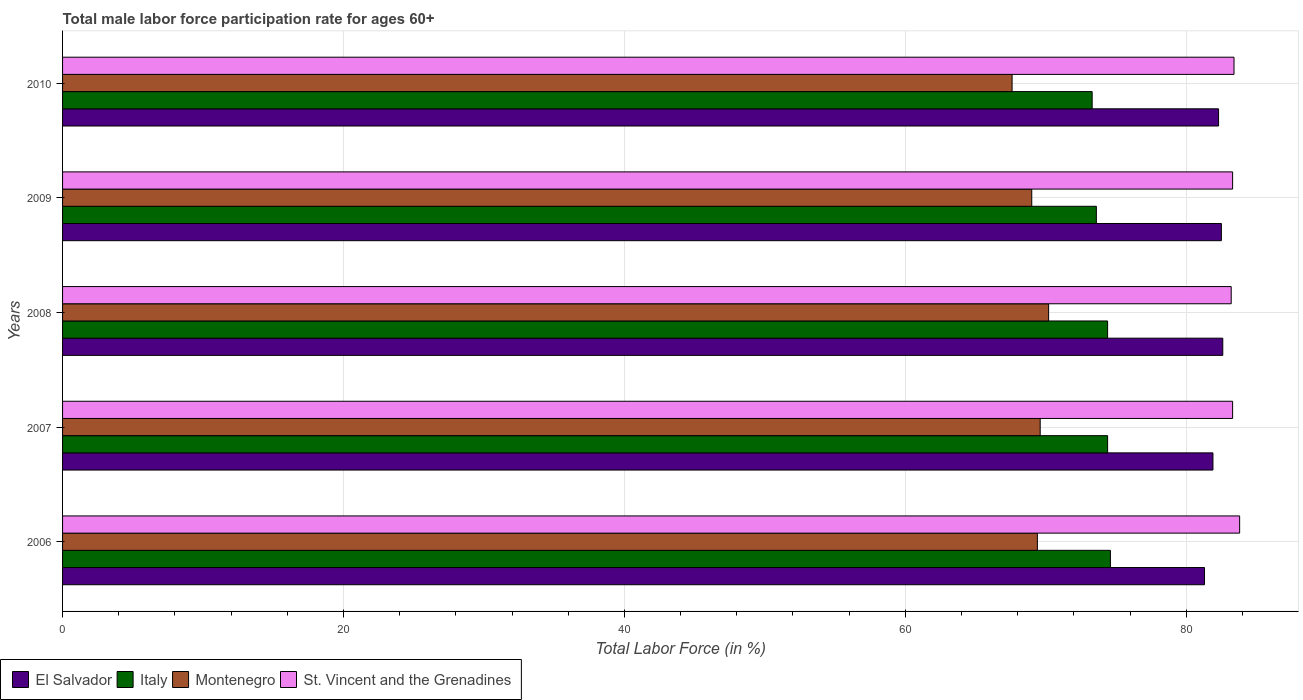How many groups of bars are there?
Keep it short and to the point. 5. Are the number of bars per tick equal to the number of legend labels?
Ensure brevity in your answer.  Yes. How many bars are there on the 3rd tick from the top?
Give a very brief answer. 4. How many bars are there on the 5th tick from the bottom?
Your answer should be very brief. 4. What is the male labor force participation rate in El Salvador in 2009?
Offer a terse response. 82.5. Across all years, what is the maximum male labor force participation rate in Montenegro?
Offer a terse response. 70.2. Across all years, what is the minimum male labor force participation rate in St. Vincent and the Grenadines?
Your answer should be compact. 83.2. In which year was the male labor force participation rate in El Salvador maximum?
Make the answer very short. 2008. What is the total male labor force participation rate in Montenegro in the graph?
Ensure brevity in your answer.  345.8. What is the difference between the male labor force participation rate in Montenegro in 2007 and that in 2009?
Keep it short and to the point. 0.6. What is the difference between the male labor force participation rate in Montenegro in 2006 and the male labor force participation rate in St. Vincent and the Grenadines in 2009?
Make the answer very short. -13.9. What is the average male labor force participation rate in Italy per year?
Your response must be concise. 74.06. In the year 2010, what is the difference between the male labor force participation rate in Italy and male labor force participation rate in St. Vincent and the Grenadines?
Ensure brevity in your answer.  -10.1. In how many years, is the male labor force participation rate in Montenegro greater than 68 %?
Your response must be concise. 4. What is the ratio of the male labor force participation rate in St. Vincent and the Grenadines in 2007 to that in 2010?
Your answer should be very brief. 1. Is the male labor force participation rate in Italy in 2008 less than that in 2010?
Provide a succinct answer. No. Is the difference between the male labor force participation rate in Italy in 2006 and 2008 greater than the difference between the male labor force participation rate in St. Vincent and the Grenadines in 2006 and 2008?
Offer a very short reply. No. What is the difference between the highest and the second highest male labor force participation rate in St. Vincent and the Grenadines?
Provide a short and direct response. 0.4. What is the difference between the highest and the lowest male labor force participation rate in El Salvador?
Your response must be concise. 1.3. In how many years, is the male labor force participation rate in Montenegro greater than the average male labor force participation rate in Montenegro taken over all years?
Keep it short and to the point. 3. Is the sum of the male labor force participation rate in Italy in 2008 and 2010 greater than the maximum male labor force participation rate in Montenegro across all years?
Ensure brevity in your answer.  Yes. Is it the case that in every year, the sum of the male labor force participation rate in St. Vincent and the Grenadines and male labor force participation rate in Italy is greater than the sum of male labor force participation rate in El Salvador and male labor force participation rate in Montenegro?
Provide a succinct answer. No. What does the 2nd bar from the top in 2007 represents?
Ensure brevity in your answer.  Montenegro. Is it the case that in every year, the sum of the male labor force participation rate in St. Vincent and the Grenadines and male labor force participation rate in Montenegro is greater than the male labor force participation rate in El Salvador?
Your response must be concise. Yes. Are all the bars in the graph horizontal?
Keep it short and to the point. Yes. How many years are there in the graph?
Your answer should be compact. 5. How are the legend labels stacked?
Your response must be concise. Horizontal. What is the title of the graph?
Your answer should be very brief. Total male labor force participation rate for ages 60+. What is the label or title of the X-axis?
Your response must be concise. Total Labor Force (in %). What is the label or title of the Y-axis?
Provide a short and direct response. Years. What is the Total Labor Force (in %) of El Salvador in 2006?
Give a very brief answer. 81.3. What is the Total Labor Force (in %) of Italy in 2006?
Provide a short and direct response. 74.6. What is the Total Labor Force (in %) in Montenegro in 2006?
Your answer should be compact. 69.4. What is the Total Labor Force (in %) in St. Vincent and the Grenadines in 2006?
Provide a short and direct response. 83.8. What is the Total Labor Force (in %) in El Salvador in 2007?
Offer a very short reply. 81.9. What is the Total Labor Force (in %) in Italy in 2007?
Your answer should be compact. 74.4. What is the Total Labor Force (in %) in Montenegro in 2007?
Your answer should be compact. 69.6. What is the Total Labor Force (in %) of St. Vincent and the Grenadines in 2007?
Your response must be concise. 83.3. What is the Total Labor Force (in %) of El Salvador in 2008?
Provide a short and direct response. 82.6. What is the Total Labor Force (in %) of Italy in 2008?
Provide a short and direct response. 74.4. What is the Total Labor Force (in %) in Montenegro in 2008?
Keep it short and to the point. 70.2. What is the Total Labor Force (in %) of St. Vincent and the Grenadines in 2008?
Provide a succinct answer. 83.2. What is the Total Labor Force (in %) in El Salvador in 2009?
Offer a very short reply. 82.5. What is the Total Labor Force (in %) of Italy in 2009?
Keep it short and to the point. 73.6. What is the Total Labor Force (in %) of St. Vincent and the Grenadines in 2009?
Offer a terse response. 83.3. What is the Total Labor Force (in %) in El Salvador in 2010?
Ensure brevity in your answer.  82.3. What is the Total Labor Force (in %) in Italy in 2010?
Offer a terse response. 73.3. What is the Total Labor Force (in %) in Montenegro in 2010?
Give a very brief answer. 67.6. What is the Total Labor Force (in %) of St. Vincent and the Grenadines in 2010?
Keep it short and to the point. 83.4. Across all years, what is the maximum Total Labor Force (in %) of El Salvador?
Give a very brief answer. 82.6. Across all years, what is the maximum Total Labor Force (in %) of Italy?
Offer a very short reply. 74.6. Across all years, what is the maximum Total Labor Force (in %) in Montenegro?
Your answer should be compact. 70.2. Across all years, what is the maximum Total Labor Force (in %) of St. Vincent and the Grenadines?
Provide a short and direct response. 83.8. Across all years, what is the minimum Total Labor Force (in %) in El Salvador?
Your answer should be compact. 81.3. Across all years, what is the minimum Total Labor Force (in %) of Italy?
Offer a terse response. 73.3. Across all years, what is the minimum Total Labor Force (in %) in Montenegro?
Offer a very short reply. 67.6. Across all years, what is the minimum Total Labor Force (in %) of St. Vincent and the Grenadines?
Offer a very short reply. 83.2. What is the total Total Labor Force (in %) of El Salvador in the graph?
Offer a terse response. 410.6. What is the total Total Labor Force (in %) in Italy in the graph?
Your answer should be very brief. 370.3. What is the total Total Labor Force (in %) in Montenegro in the graph?
Provide a short and direct response. 345.8. What is the total Total Labor Force (in %) of St. Vincent and the Grenadines in the graph?
Offer a very short reply. 417. What is the difference between the Total Labor Force (in %) of Italy in 2006 and that in 2007?
Offer a very short reply. 0.2. What is the difference between the Total Labor Force (in %) in El Salvador in 2006 and that in 2008?
Offer a terse response. -1.3. What is the difference between the Total Labor Force (in %) in Italy in 2006 and that in 2008?
Make the answer very short. 0.2. What is the difference between the Total Labor Force (in %) of El Salvador in 2006 and that in 2009?
Offer a terse response. -1.2. What is the difference between the Total Labor Force (in %) of Italy in 2006 and that in 2009?
Your answer should be compact. 1. What is the difference between the Total Labor Force (in %) of St. Vincent and the Grenadines in 2006 and that in 2009?
Provide a succinct answer. 0.5. What is the difference between the Total Labor Force (in %) of Montenegro in 2006 and that in 2010?
Keep it short and to the point. 1.8. What is the difference between the Total Labor Force (in %) in St. Vincent and the Grenadines in 2006 and that in 2010?
Offer a terse response. 0.4. What is the difference between the Total Labor Force (in %) in El Salvador in 2007 and that in 2008?
Your answer should be very brief. -0.7. What is the difference between the Total Labor Force (in %) in Italy in 2007 and that in 2008?
Offer a terse response. 0. What is the difference between the Total Labor Force (in %) of Montenegro in 2007 and that in 2008?
Ensure brevity in your answer.  -0.6. What is the difference between the Total Labor Force (in %) of St. Vincent and the Grenadines in 2007 and that in 2008?
Provide a short and direct response. 0.1. What is the difference between the Total Labor Force (in %) in El Salvador in 2007 and that in 2009?
Offer a terse response. -0.6. What is the difference between the Total Labor Force (in %) in Italy in 2007 and that in 2009?
Your answer should be compact. 0.8. What is the difference between the Total Labor Force (in %) of St. Vincent and the Grenadines in 2007 and that in 2009?
Make the answer very short. 0. What is the difference between the Total Labor Force (in %) of Italy in 2007 and that in 2010?
Provide a succinct answer. 1.1. What is the difference between the Total Labor Force (in %) of St. Vincent and the Grenadines in 2007 and that in 2010?
Offer a very short reply. -0.1. What is the difference between the Total Labor Force (in %) in Montenegro in 2008 and that in 2009?
Give a very brief answer. 1.2. What is the difference between the Total Labor Force (in %) of St. Vincent and the Grenadines in 2008 and that in 2009?
Your response must be concise. -0.1. What is the difference between the Total Labor Force (in %) in Montenegro in 2008 and that in 2010?
Offer a very short reply. 2.6. What is the difference between the Total Labor Force (in %) of St. Vincent and the Grenadines in 2008 and that in 2010?
Make the answer very short. -0.2. What is the difference between the Total Labor Force (in %) in El Salvador in 2009 and that in 2010?
Your answer should be very brief. 0.2. What is the difference between the Total Labor Force (in %) in Italy in 2009 and that in 2010?
Your response must be concise. 0.3. What is the difference between the Total Labor Force (in %) of El Salvador in 2006 and the Total Labor Force (in %) of Italy in 2007?
Give a very brief answer. 6.9. What is the difference between the Total Labor Force (in %) of El Salvador in 2006 and the Total Labor Force (in %) of Montenegro in 2007?
Give a very brief answer. 11.7. What is the difference between the Total Labor Force (in %) in El Salvador in 2006 and the Total Labor Force (in %) in St. Vincent and the Grenadines in 2007?
Offer a very short reply. -2. What is the difference between the Total Labor Force (in %) of Italy in 2006 and the Total Labor Force (in %) of St. Vincent and the Grenadines in 2007?
Your answer should be very brief. -8.7. What is the difference between the Total Labor Force (in %) in Montenegro in 2006 and the Total Labor Force (in %) in St. Vincent and the Grenadines in 2007?
Offer a terse response. -13.9. What is the difference between the Total Labor Force (in %) in El Salvador in 2006 and the Total Labor Force (in %) in Italy in 2008?
Ensure brevity in your answer.  6.9. What is the difference between the Total Labor Force (in %) in El Salvador in 2006 and the Total Labor Force (in %) in St. Vincent and the Grenadines in 2008?
Provide a short and direct response. -1.9. What is the difference between the Total Labor Force (in %) of El Salvador in 2006 and the Total Labor Force (in %) of Italy in 2009?
Your response must be concise. 7.7. What is the difference between the Total Labor Force (in %) in El Salvador in 2006 and the Total Labor Force (in %) in Italy in 2010?
Keep it short and to the point. 8. What is the difference between the Total Labor Force (in %) in El Salvador in 2006 and the Total Labor Force (in %) in St. Vincent and the Grenadines in 2010?
Your response must be concise. -2.1. What is the difference between the Total Labor Force (in %) of Italy in 2006 and the Total Labor Force (in %) of Montenegro in 2010?
Ensure brevity in your answer.  7. What is the difference between the Total Labor Force (in %) of Italy in 2006 and the Total Labor Force (in %) of St. Vincent and the Grenadines in 2010?
Provide a short and direct response. -8.8. What is the difference between the Total Labor Force (in %) in Montenegro in 2006 and the Total Labor Force (in %) in St. Vincent and the Grenadines in 2010?
Offer a terse response. -14. What is the difference between the Total Labor Force (in %) in El Salvador in 2007 and the Total Labor Force (in %) in Italy in 2008?
Provide a short and direct response. 7.5. What is the difference between the Total Labor Force (in %) of El Salvador in 2007 and the Total Labor Force (in %) of Montenegro in 2008?
Your answer should be compact. 11.7. What is the difference between the Total Labor Force (in %) of Italy in 2007 and the Total Labor Force (in %) of Montenegro in 2008?
Your answer should be very brief. 4.2. What is the difference between the Total Labor Force (in %) in Italy in 2007 and the Total Labor Force (in %) in St. Vincent and the Grenadines in 2008?
Give a very brief answer. -8.8. What is the difference between the Total Labor Force (in %) of El Salvador in 2007 and the Total Labor Force (in %) of Italy in 2009?
Your answer should be compact. 8.3. What is the difference between the Total Labor Force (in %) in El Salvador in 2007 and the Total Labor Force (in %) in St. Vincent and the Grenadines in 2009?
Offer a very short reply. -1.4. What is the difference between the Total Labor Force (in %) in Italy in 2007 and the Total Labor Force (in %) in Montenegro in 2009?
Provide a succinct answer. 5.4. What is the difference between the Total Labor Force (in %) of Italy in 2007 and the Total Labor Force (in %) of St. Vincent and the Grenadines in 2009?
Offer a terse response. -8.9. What is the difference between the Total Labor Force (in %) of Montenegro in 2007 and the Total Labor Force (in %) of St. Vincent and the Grenadines in 2009?
Your answer should be very brief. -13.7. What is the difference between the Total Labor Force (in %) of Italy in 2007 and the Total Labor Force (in %) of Montenegro in 2010?
Offer a very short reply. 6.8. What is the difference between the Total Labor Force (in %) in El Salvador in 2008 and the Total Labor Force (in %) in Italy in 2009?
Give a very brief answer. 9. What is the difference between the Total Labor Force (in %) in El Salvador in 2008 and the Total Labor Force (in %) in Montenegro in 2009?
Your answer should be compact. 13.6. What is the difference between the Total Labor Force (in %) in El Salvador in 2008 and the Total Labor Force (in %) in St. Vincent and the Grenadines in 2009?
Make the answer very short. -0.7. What is the difference between the Total Labor Force (in %) of Montenegro in 2008 and the Total Labor Force (in %) of St. Vincent and the Grenadines in 2009?
Give a very brief answer. -13.1. What is the difference between the Total Labor Force (in %) in El Salvador in 2008 and the Total Labor Force (in %) in Italy in 2010?
Ensure brevity in your answer.  9.3. What is the difference between the Total Labor Force (in %) of El Salvador in 2008 and the Total Labor Force (in %) of St. Vincent and the Grenadines in 2010?
Provide a succinct answer. -0.8. What is the difference between the Total Labor Force (in %) in El Salvador in 2009 and the Total Labor Force (in %) in Italy in 2010?
Make the answer very short. 9.2. What is the difference between the Total Labor Force (in %) in Montenegro in 2009 and the Total Labor Force (in %) in St. Vincent and the Grenadines in 2010?
Offer a very short reply. -14.4. What is the average Total Labor Force (in %) in El Salvador per year?
Provide a short and direct response. 82.12. What is the average Total Labor Force (in %) in Italy per year?
Keep it short and to the point. 74.06. What is the average Total Labor Force (in %) of Montenegro per year?
Provide a short and direct response. 69.16. What is the average Total Labor Force (in %) in St. Vincent and the Grenadines per year?
Offer a terse response. 83.4. In the year 2006, what is the difference between the Total Labor Force (in %) of El Salvador and Total Labor Force (in %) of St. Vincent and the Grenadines?
Provide a succinct answer. -2.5. In the year 2006, what is the difference between the Total Labor Force (in %) in Montenegro and Total Labor Force (in %) in St. Vincent and the Grenadines?
Ensure brevity in your answer.  -14.4. In the year 2007, what is the difference between the Total Labor Force (in %) of Italy and Total Labor Force (in %) of St. Vincent and the Grenadines?
Ensure brevity in your answer.  -8.9. In the year 2007, what is the difference between the Total Labor Force (in %) of Montenegro and Total Labor Force (in %) of St. Vincent and the Grenadines?
Your answer should be compact. -13.7. In the year 2008, what is the difference between the Total Labor Force (in %) in El Salvador and Total Labor Force (in %) in St. Vincent and the Grenadines?
Your answer should be compact. -0.6. In the year 2008, what is the difference between the Total Labor Force (in %) in Montenegro and Total Labor Force (in %) in St. Vincent and the Grenadines?
Provide a short and direct response. -13. In the year 2009, what is the difference between the Total Labor Force (in %) of El Salvador and Total Labor Force (in %) of Montenegro?
Offer a terse response. 13.5. In the year 2009, what is the difference between the Total Labor Force (in %) of Italy and Total Labor Force (in %) of St. Vincent and the Grenadines?
Give a very brief answer. -9.7. In the year 2009, what is the difference between the Total Labor Force (in %) of Montenegro and Total Labor Force (in %) of St. Vincent and the Grenadines?
Provide a succinct answer. -14.3. In the year 2010, what is the difference between the Total Labor Force (in %) in Italy and Total Labor Force (in %) in St. Vincent and the Grenadines?
Provide a succinct answer. -10.1. In the year 2010, what is the difference between the Total Labor Force (in %) of Montenegro and Total Labor Force (in %) of St. Vincent and the Grenadines?
Your answer should be very brief. -15.8. What is the ratio of the Total Labor Force (in %) of El Salvador in 2006 to that in 2008?
Your answer should be compact. 0.98. What is the ratio of the Total Labor Force (in %) of Italy in 2006 to that in 2008?
Your answer should be very brief. 1. What is the ratio of the Total Labor Force (in %) in Montenegro in 2006 to that in 2008?
Give a very brief answer. 0.99. What is the ratio of the Total Labor Force (in %) in St. Vincent and the Grenadines in 2006 to that in 2008?
Keep it short and to the point. 1.01. What is the ratio of the Total Labor Force (in %) of El Salvador in 2006 to that in 2009?
Your answer should be very brief. 0.99. What is the ratio of the Total Labor Force (in %) in Italy in 2006 to that in 2009?
Keep it short and to the point. 1.01. What is the ratio of the Total Labor Force (in %) of Montenegro in 2006 to that in 2009?
Your answer should be very brief. 1.01. What is the ratio of the Total Labor Force (in %) in St. Vincent and the Grenadines in 2006 to that in 2009?
Your answer should be very brief. 1.01. What is the ratio of the Total Labor Force (in %) in Italy in 2006 to that in 2010?
Offer a terse response. 1.02. What is the ratio of the Total Labor Force (in %) of Montenegro in 2006 to that in 2010?
Keep it short and to the point. 1.03. What is the ratio of the Total Labor Force (in %) of St. Vincent and the Grenadines in 2006 to that in 2010?
Ensure brevity in your answer.  1. What is the ratio of the Total Labor Force (in %) in El Salvador in 2007 to that in 2008?
Provide a short and direct response. 0.99. What is the ratio of the Total Labor Force (in %) in St. Vincent and the Grenadines in 2007 to that in 2008?
Provide a succinct answer. 1. What is the ratio of the Total Labor Force (in %) of Italy in 2007 to that in 2009?
Give a very brief answer. 1.01. What is the ratio of the Total Labor Force (in %) of Montenegro in 2007 to that in 2009?
Ensure brevity in your answer.  1.01. What is the ratio of the Total Labor Force (in %) in Montenegro in 2007 to that in 2010?
Offer a terse response. 1.03. What is the ratio of the Total Labor Force (in %) in Italy in 2008 to that in 2009?
Provide a succinct answer. 1.01. What is the ratio of the Total Labor Force (in %) in Montenegro in 2008 to that in 2009?
Offer a very short reply. 1.02. What is the ratio of the Total Labor Force (in %) in St. Vincent and the Grenadines in 2008 to that in 2009?
Give a very brief answer. 1. What is the ratio of the Total Labor Force (in %) in Montenegro in 2008 to that in 2010?
Offer a very short reply. 1.04. What is the ratio of the Total Labor Force (in %) of St. Vincent and the Grenadines in 2008 to that in 2010?
Your answer should be very brief. 1. What is the ratio of the Total Labor Force (in %) of Montenegro in 2009 to that in 2010?
Your response must be concise. 1.02. What is the difference between the highest and the second highest Total Labor Force (in %) in Montenegro?
Give a very brief answer. 0.6. What is the difference between the highest and the second highest Total Labor Force (in %) of St. Vincent and the Grenadines?
Keep it short and to the point. 0.4. What is the difference between the highest and the lowest Total Labor Force (in %) in Montenegro?
Your response must be concise. 2.6. What is the difference between the highest and the lowest Total Labor Force (in %) of St. Vincent and the Grenadines?
Your answer should be very brief. 0.6. 